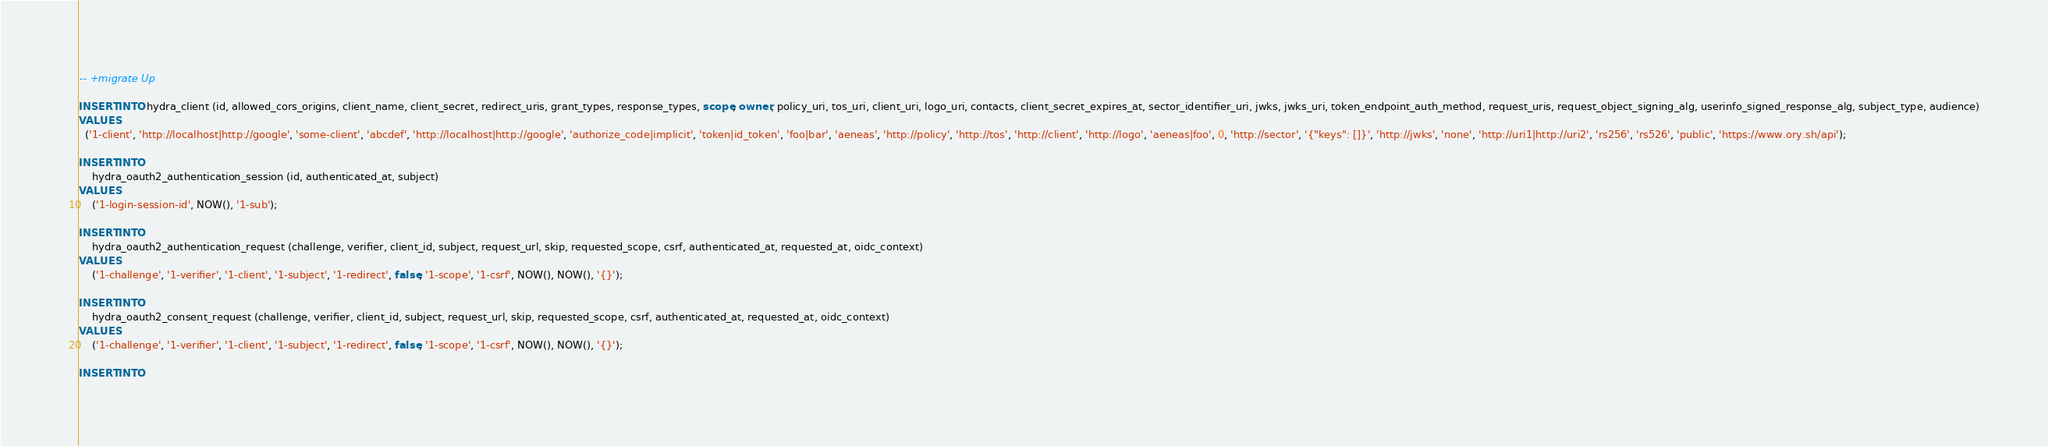Convert code to text. <code><loc_0><loc_0><loc_500><loc_500><_SQL_>-- +migrate Up

INSERT INTO hydra_client (id, allowed_cors_origins, client_name, client_secret, redirect_uris, grant_types, response_types, scope, owner, policy_uri, tos_uri, client_uri, logo_uri, contacts, client_secret_expires_at, sector_identifier_uri, jwks, jwks_uri, token_endpoint_auth_method, request_uris, request_object_signing_alg, userinfo_signed_response_alg, subject_type, audience)
VALUES
  ('1-client', 'http://localhost|http://google', 'some-client', 'abcdef', 'http://localhost|http://google', 'authorize_code|implicit', 'token|id_token', 'foo|bar', 'aeneas', 'http://policy', 'http://tos', 'http://client', 'http://logo', 'aeneas|foo', 0, 'http://sector', '{"keys": []}', 'http://jwks', 'none', 'http://uri1|http://uri2', 'rs256', 'rs526', 'public', 'https://www.ory.sh/api');

INSERT INTO
	hydra_oauth2_authentication_session (id, authenticated_at, subject)
VALUES
	('1-login-session-id', NOW(), '1-sub');

INSERT INTO
	hydra_oauth2_authentication_request (challenge, verifier, client_id, subject, request_url, skip, requested_scope, csrf, authenticated_at, requested_at, oidc_context)
VALUES
	('1-challenge', '1-verifier', '1-client', '1-subject', '1-redirect', false, '1-scope', '1-csrf', NOW(), NOW(), '{}');

INSERT INTO
	hydra_oauth2_consent_request (challenge, verifier, client_id, subject, request_url, skip, requested_scope, csrf, authenticated_at, requested_at, oidc_context)
VALUES
	('1-challenge', '1-verifier', '1-client', '1-subject', '1-redirect', false, '1-scope', '1-csrf', NOW(), NOW(), '{}');

INSERT INTO</code> 